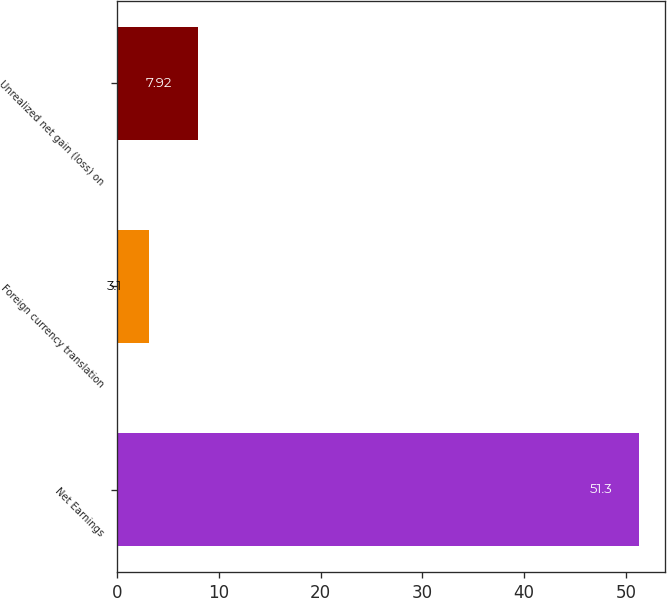<chart> <loc_0><loc_0><loc_500><loc_500><bar_chart><fcel>Net Earnings<fcel>Foreign currency translation<fcel>Unrealized net gain (loss) on<nl><fcel>51.3<fcel>3.1<fcel>7.92<nl></chart> 